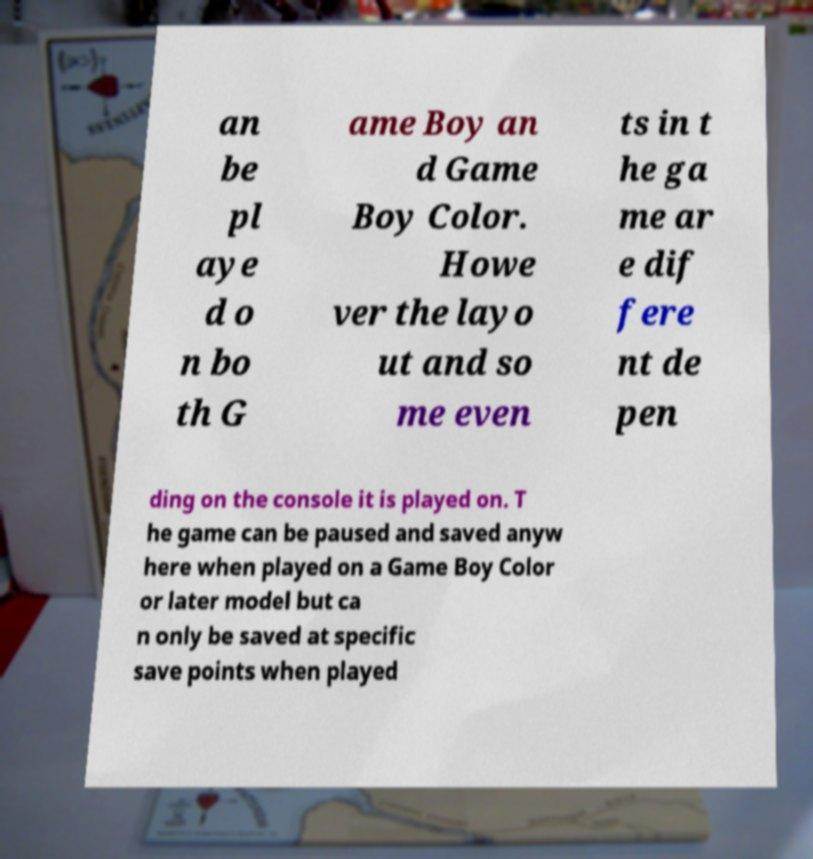Please read and relay the text visible in this image. What does it say? an be pl aye d o n bo th G ame Boy an d Game Boy Color. Howe ver the layo ut and so me even ts in t he ga me ar e dif fere nt de pen ding on the console it is played on. T he game can be paused and saved anyw here when played on a Game Boy Color or later model but ca n only be saved at specific save points when played 